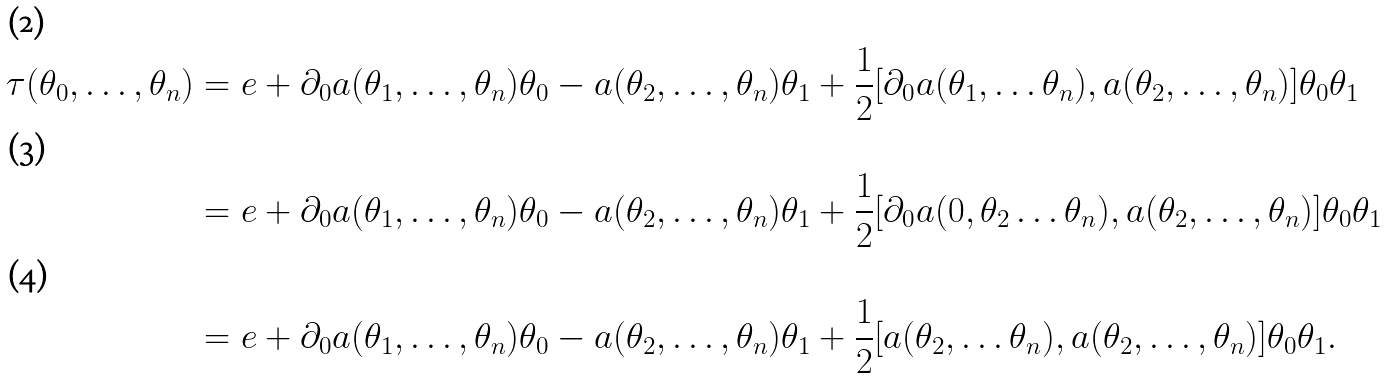Convert formula to latex. <formula><loc_0><loc_0><loc_500><loc_500>\tau ( \theta _ { 0 } , \dots , \theta _ { n } ) & = e + \partial _ { 0 } a ( \theta _ { 1 } , \dots , \theta _ { n } ) \theta _ { 0 } - a ( \theta _ { 2 } , \dots , \theta _ { n } ) \theta _ { 1 } + \frac { 1 } { 2 } [ \partial _ { 0 } a ( \theta _ { 1 } , \dots \theta _ { n } ) , a ( \theta _ { 2 } , \dots , \theta _ { n } ) ] \theta _ { 0 } \theta _ { 1 } \\ & = e + \partial _ { 0 } a ( \theta _ { 1 } , \dots , \theta _ { n } ) \theta _ { 0 } - a ( \theta _ { 2 } , \dots , \theta _ { n } ) \theta _ { 1 } + \frac { 1 } { 2 } [ \partial _ { 0 } a ( 0 , \theta _ { 2 } \dots \theta _ { n } ) , a ( \theta _ { 2 } , \dots , \theta _ { n } ) ] \theta _ { 0 } \theta _ { 1 } \\ & = e + \partial _ { 0 } a ( \theta _ { 1 } , \dots , \theta _ { n } ) \theta _ { 0 } - a ( \theta _ { 2 } , \dots , \theta _ { n } ) \theta _ { 1 } + \frac { 1 } { 2 } [ a ( \theta _ { 2 } , \dots \theta _ { n } ) , a ( \theta _ { 2 } , \dots , \theta _ { n } ) ] \theta _ { 0 } \theta _ { 1 } .</formula> 